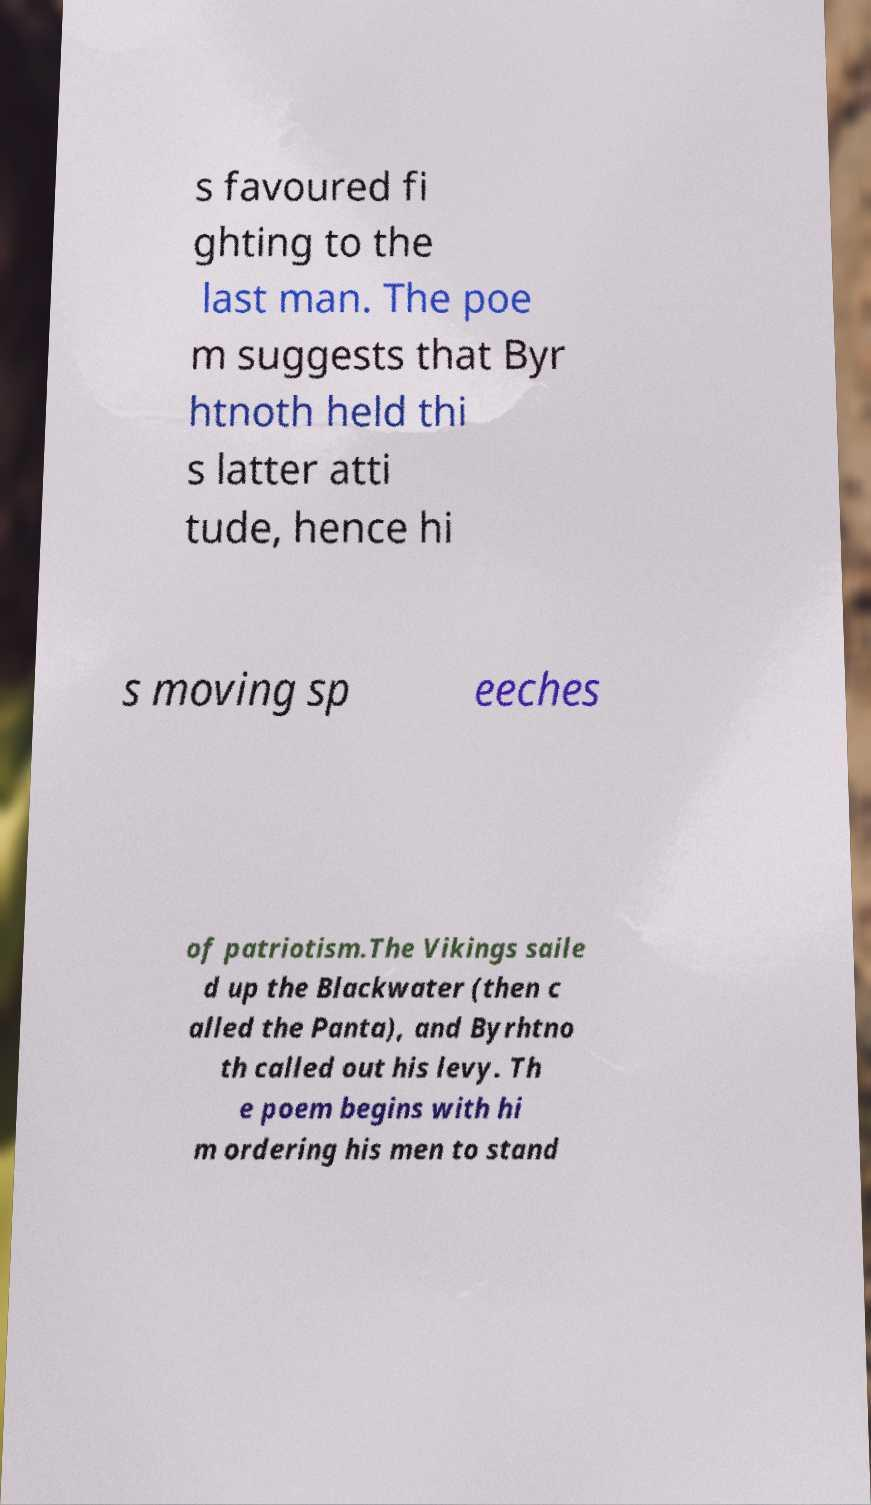Can you read and provide the text displayed in the image?This photo seems to have some interesting text. Can you extract and type it out for me? s favoured fi ghting to the last man. The poe m suggests that Byr htnoth held thi s latter atti tude, hence hi s moving sp eeches of patriotism.The Vikings saile d up the Blackwater (then c alled the Panta), and Byrhtno th called out his levy. Th e poem begins with hi m ordering his men to stand 